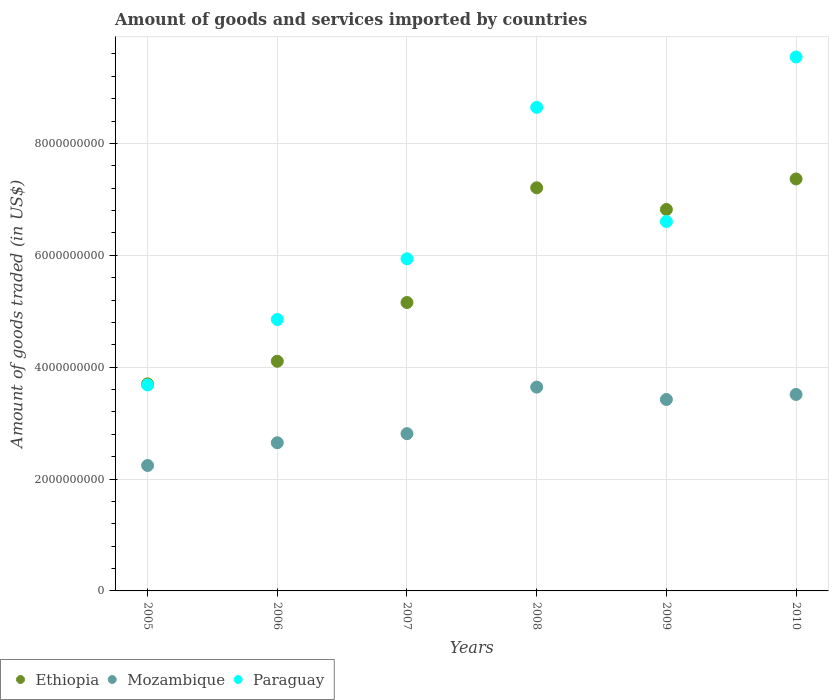Is the number of dotlines equal to the number of legend labels?
Your answer should be very brief. Yes. What is the total amount of goods and services imported in Paraguay in 2010?
Provide a short and direct response. 9.54e+09. Across all years, what is the maximum total amount of goods and services imported in Ethiopia?
Offer a terse response. 7.36e+09. Across all years, what is the minimum total amount of goods and services imported in Ethiopia?
Provide a short and direct response. 3.70e+09. In which year was the total amount of goods and services imported in Paraguay minimum?
Make the answer very short. 2005. What is the total total amount of goods and services imported in Ethiopia in the graph?
Your answer should be compact. 3.44e+1. What is the difference between the total amount of goods and services imported in Paraguay in 2008 and that in 2009?
Your answer should be compact. 2.04e+09. What is the difference between the total amount of goods and services imported in Mozambique in 2006 and the total amount of goods and services imported in Ethiopia in 2009?
Offer a very short reply. -4.17e+09. What is the average total amount of goods and services imported in Paraguay per year?
Offer a terse response. 6.54e+09. In the year 2010, what is the difference between the total amount of goods and services imported in Paraguay and total amount of goods and services imported in Mozambique?
Your response must be concise. 6.03e+09. What is the ratio of the total amount of goods and services imported in Mozambique in 2005 to that in 2006?
Make the answer very short. 0.85. Is the total amount of goods and services imported in Ethiopia in 2005 less than that in 2006?
Provide a short and direct response. Yes. Is the difference between the total amount of goods and services imported in Paraguay in 2007 and 2008 greater than the difference between the total amount of goods and services imported in Mozambique in 2007 and 2008?
Keep it short and to the point. No. What is the difference between the highest and the second highest total amount of goods and services imported in Mozambique?
Ensure brevity in your answer.  1.31e+08. What is the difference between the highest and the lowest total amount of goods and services imported in Ethiopia?
Give a very brief answer. 3.66e+09. Is the total amount of goods and services imported in Ethiopia strictly greater than the total amount of goods and services imported in Mozambique over the years?
Provide a succinct answer. Yes. Is the total amount of goods and services imported in Mozambique strictly less than the total amount of goods and services imported in Ethiopia over the years?
Your answer should be compact. Yes. How many years are there in the graph?
Ensure brevity in your answer.  6. Are the values on the major ticks of Y-axis written in scientific E-notation?
Keep it short and to the point. No. Does the graph contain any zero values?
Keep it short and to the point. No. Does the graph contain grids?
Your answer should be very brief. Yes. Where does the legend appear in the graph?
Your answer should be compact. Bottom left. How many legend labels are there?
Offer a very short reply. 3. What is the title of the graph?
Give a very brief answer. Amount of goods and services imported by countries. What is the label or title of the Y-axis?
Your answer should be compact. Amount of goods traded (in US$). What is the Amount of goods traded (in US$) of Ethiopia in 2005?
Your answer should be very brief. 3.70e+09. What is the Amount of goods traded (in US$) of Mozambique in 2005?
Provide a succinct answer. 2.24e+09. What is the Amount of goods traded (in US$) of Paraguay in 2005?
Provide a short and direct response. 3.68e+09. What is the Amount of goods traded (in US$) in Ethiopia in 2006?
Your answer should be very brief. 4.11e+09. What is the Amount of goods traded (in US$) in Mozambique in 2006?
Keep it short and to the point. 2.65e+09. What is the Amount of goods traded (in US$) in Paraguay in 2006?
Provide a succinct answer. 4.85e+09. What is the Amount of goods traded (in US$) of Ethiopia in 2007?
Your answer should be very brief. 5.16e+09. What is the Amount of goods traded (in US$) of Mozambique in 2007?
Provide a short and direct response. 2.81e+09. What is the Amount of goods traded (in US$) in Paraguay in 2007?
Offer a very short reply. 5.94e+09. What is the Amount of goods traded (in US$) in Ethiopia in 2008?
Offer a terse response. 7.21e+09. What is the Amount of goods traded (in US$) in Mozambique in 2008?
Offer a terse response. 3.64e+09. What is the Amount of goods traded (in US$) of Paraguay in 2008?
Ensure brevity in your answer.  8.64e+09. What is the Amount of goods traded (in US$) of Ethiopia in 2009?
Your answer should be compact. 6.82e+09. What is the Amount of goods traded (in US$) in Mozambique in 2009?
Your response must be concise. 3.42e+09. What is the Amount of goods traded (in US$) of Paraguay in 2009?
Ensure brevity in your answer.  6.60e+09. What is the Amount of goods traded (in US$) in Ethiopia in 2010?
Make the answer very short. 7.36e+09. What is the Amount of goods traded (in US$) of Mozambique in 2010?
Your response must be concise. 3.51e+09. What is the Amount of goods traded (in US$) in Paraguay in 2010?
Your answer should be very brief. 9.54e+09. Across all years, what is the maximum Amount of goods traded (in US$) in Ethiopia?
Give a very brief answer. 7.36e+09. Across all years, what is the maximum Amount of goods traded (in US$) in Mozambique?
Make the answer very short. 3.64e+09. Across all years, what is the maximum Amount of goods traded (in US$) of Paraguay?
Your answer should be very brief. 9.54e+09. Across all years, what is the minimum Amount of goods traded (in US$) of Ethiopia?
Your answer should be very brief. 3.70e+09. Across all years, what is the minimum Amount of goods traded (in US$) in Mozambique?
Provide a short and direct response. 2.24e+09. Across all years, what is the minimum Amount of goods traded (in US$) in Paraguay?
Your answer should be compact. 3.68e+09. What is the total Amount of goods traded (in US$) of Ethiopia in the graph?
Keep it short and to the point. 3.44e+1. What is the total Amount of goods traded (in US$) in Mozambique in the graph?
Provide a short and direct response. 1.83e+1. What is the total Amount of goods traded (in US$) in Paraguay in the graph?
Your response must be concise. 3.93e+1. What is the difference between the Amount of goods traded (in US$) of Ethiopia in 2005 and that in 2006?
Make the answer very short. -4.05e+08. What is the difference between the Amount of goods traded (in US$) in Mozambique in 2005 and that in 2006?
Keep it short and to the point. -4.07e+08. What is the difference between the Amount of goods traded (in US$) in Paraguay in 2005 and that in 2006?
Your answer should be compact. -1.17e+09. What is the difference between the Amount of goods traded (in US$) in Ethiopia in 2005 and that in 2007?
Offer a terse response. -1.45e+09. What is the difference between the Amount of goods traded (in US$) in Mozambique in 2005 and that in 2007?
Make the answer very short. -5.69e+08. What is the difference between the Amount of goods traded (in US$) in Paraguay in 2005 and that in 2007?
Provide a succinct answer. -2.26e+09. What is the difference between the Amount of goods traded (in US$) of Ethiopia in 2005 and that in 2008?
Your answer should be compact. -3.51e+09. What is the difference between the Amount of goods traded (in US$) in Mozambique in 2005 and that in 2008?
Your response must be concise. -1.40e+09. What is the difference between the Amount of goods traded (in US$) of Paraguay in 2005 and that in 2008?
Keep it short and to the point. -4.96e+09. What is the difference between the Amount of goods traded (in US$) of Ethiopia in 2005 and that in 2009?
Offer a terse response. -3.12e+09. What is the difference between the Amount of goods traded (in US$) in Mozambique in 2005 and that in 2009?
Give a very brief answer. -1.18e+09. What is the difference between the Amount of goods traded (in US$) of Paraguay in 2005 and that in 2009?
Provide a succinct answer. -2.92e+09. What is the difference between the Amount of goods traded (in US$) in Ethiopia in 2005 and that in 2010?
Your response must be concise. -3.66e+09. What is the difference between the Amount of goods traded (in US$) in Mozambique in 2005 and that in 2010?
Your response must be concise. -1.27e+09. What is the difference between the Amount of goods traded (in US$) in Paraguay in 2005 and that in 2010?
Provide a short and direct response. -5.86e+09. What is the difference between the Amount of goods traded (in US$) of Ethiopia in 2006 and that in 2007?
Offer a terse response. -1.05e+09. What is the difference between the Amount of goods traded (in US$) in Mozambique in 2006 and that in 2007?
Provide a short and direct response. -1.62e+08. What is the difference between the Amount of goods traded (in US$) of Paraguay in 2006 and that in 2007?
Offer a terse response. -1.08e+09. What is the difference between the Amount of goods traded (in US$) of Ethiopia in 2006 and that in 2008?
Offer a terse response. -3.10e+09. What is the difference between the Amount of goods traded (in US$) of Mozambique in 2006 and that in 2008?
Your answer should be compact. -9.95e+08. What is the difference between the Amount of goods traded (in US$) in Paraguay in 2006 and that in 2008?
Give a very brief answer. -3.79e+09. What is the difference between the Amount of goods traded (in US$) of Ethiopia in 2006 and that in 2009?
Offer a very short reply. -2.71e+09. What is the difference between the Amount of goods traded (in US$) of Mozambique in 2006 and that in 2009?
Ensure brevity in your answer.  -7.73e+08. What is the difference between the Amount of goods traded (in US$) in Paraguay in 2006 and that in 2009?
Your answer should be very brief. -1.75e+09. What is the difference between the Amount of goods traded (in US$) of Ethiopia in 2006 and that in 2010?
Your response must be concise. -3.26e+09. What is the difference between the Amount of goods traded (in US$) in Mozambique in 2006 and that in 2010?
Your answer should be compact. -8.64e+08. What is the difference between the Amount of goods traded (in US$) of Paraguay in 2006 and that in 2010?
Provide a succinct answer. -4.69e+09. What is the difference between the Amount of goods traded (in US$) of Ethiopia in 2007 and that in 2008?
Ensure brevity in your answer.  -2.05e+09. What is the difference between the Amount of goods traded (in US$) in Mozambique in 2007 and that in 2008?
Keep it short and to the point. -8.32e+08. What is the difference between the Amount of goods traded (in US$) in Paraguay in 2007 and that in 2008?
Give a very brief answer. -2.71e+09. What is the difference between the Amount of goods traded (in US$) in Ethiopia in 2007 and that in 2009?
Your answer should be very brief. -1.66e+09. What is the difference between the Amount of goods traded (in US$) in Mozambique in 2007 and that in 2009?
Make the answer very short. -6.11e+08. What is the difference between the Amount of goods traded (in US$) in Paraguay in 2007 and that in 2009?
Offer a very short reply. -6.66e+08. What is the difference between the Amount of goods traded (in US$) of Ethiopia in 2007 and that in 2010?
Ensure brevity in your answer.  -2.21e+09. What is the difference between the Amount of goods traded (in US$) of Mozambique in 2007 and that in 2010?
Provide a short and direct response. -7.01e+08. What is the difference between the Amount of goods traded (in US$) in Paraguay in 2007 and that in 2010?
Keep it short and to the point. -3.61e+09. What is the difference between the Amount of goods traded (in US$) in Ethiopia in 2008 and that in 2009?
Keep it short and to the point. 3.87e+08. What is the difference between the Amount of goods traded (in US$) in Mozambique in 2008 and that in 2009?
Make the answer very short. 2.21e+08. What is the difference between the Amount of goods traded (in US$) of Paraguay in 2008 and that in 2009?
Provide a succinct answer. 2.04e+09. What is the difference between the Amount of goods traded (in US$) of Ethiopia in 2008 and that in 2010?
Keep it short and to the point. -1.58e+08. What is the difference between the Amount of goods traded (in US$) in Mozambique in 2008 and that in 2010?
Offer a terse response. 1.31e+08. What is the difference between the Amount of goods traded (in US$) in Paraguay in 2008 and that in 2010?
Ensure brevity in your answer.  -9.00e+08. What is the difference between the Amount of goods traded (in US$) in Ethiopia in 2009 and that in 2010?
Your answer should be compact. -5.45e+08. What is the difference between the Amount of goods traded (in US$) of Mozambique in 2009 and that in 2010?
Make the answer very short. -9.04e+07. What is the difference between the Amount of goods traded (in US$) of Paraguay in 2009 and that in 2010?
Ensure brevity in your answer.  -2.94e+09. What is the difference between the Amount of goods traded (in US$) of Ethiopia in 2005 and the Amount of goods traded (in US$) of Mozambique in 2006?
Offer a very short reply. 1.05e+09. What is the difference between the Amount of goods traded (in US$) of Ethiopia in 2005 and the Amount of goods traded (in US$) of Paraguay in 2006?
Offer a very short reply. -1.15e+09. What is the difference between the Amount of goods traded (in US$) in Mozambique in 2005 and the Amount of goods traded (in US$) in Paraguay in 2006?
Provide a short and direct response. -2.61e+09. What is the difference between the Amount of goods traded (in US$) of Ethiopia in 2005 and the Amount of goods traded (in US$) of Mozambique in 2007?
Offer a terse response. 8.90e+08. What is the difference between the Amount of goods traded (in US$) of Ethiopia in 2005 and the Amount of goods traded (in US$) of Paraguay in 2007?
Keep it short and to the point. -2.24e+09. What is the difference between the Amount of goods traded (in US$) in Mozambique in 2005 and the Amount of goods traded (in US$) in Paraguay in 2007?
Offer a terse response. -3.70e+09. What is the difference between the Amount of goods traded (in US$) in Ethiopia in 2005 and the Amount of goods traded (in US$) in Mozambique in 2008?
Keep it short and to the point. 5.74e+07. What is the difference between the Amount of goods traded (in US$) of Ethiopia in 2005 and the Amount of goods traded (in US$) of Paraguay in 2008?
Your response must be concise. -4.94e+09. What is the difference between the Amount of goods traded (in US$) in Mozambique in 2005 and the Amount of goods traded (in US$) in Paraguay in 2008?
Provide a succinct answer. -6.40e+09. What is the difference between the Amount of goods traded (in US$) in Ethiopia in 2005 and the Amount of goods traded (in US$) in Mozambique in 2009?
Give a very brief answer. 2.79e+08. What is the difference between the Amount of goods traded (in US$) in Ethiopia in 2005 and the Amount of goods traded (in US$) in Paraguay in 2009?
Keep it short and to the point. -2.90e+09. What is the difference between the Amount of goods traded (in US$) of Mozambique in 2005 and the Amount of goods traded (in US$) of Paraguay in 2009?
Ensure brevity in your answer.  -4.36e+09. What is the difference between the Amount of goods traded (in US$) of Ethiopia in 2005 and the Amount of goods traded (in US$) of Mozambique in 2010?
Make the answer very short. 1.88e+08. What is the difference between the Amount of goods traded (in US$) in Ethiopia in 2005 and the Amount of goods traded (in US$) in Paraguay in 2010?
Your answer should be compact. -5.84e+09. What is the difference between the Amount of goods traded (in US$) in Mozambique in 2005 and the Amount of goods traded (in US$) in Paraguay in 2010?
Your answer should be compact. -7.30e+09. What is the difference between the Amount of goods traded (in US$) in Ethiopia in 2006 and the Amount of goods traded (in US$) in Mozambique in 2007?
Make the answer very short. 1.29e+09. What is the difference between the Amount of goods traded (in US$) of Ethiopia in 2006 and the Amount of goods traded (in US$) of Paraguay in 2007?
Provide a succinct answer. -1.83e+09. What is the difference between the Amount of goods traded (in US$) of Mozambique in 2006 and the Amount of goods traded (in US$) of Paraguay in 2007?
Offer a terse response. -3.29e+09. What is the difference between the Amount of goods traded (in US$) in Ethiopia in 2006 and the Amount of goods traded (in US$) in Mozambique in 2008?
Make the answer very short. 4.62e+08. What is the difference between the Amount of goods traded (in US$) in Ethiopia in 2006 and the Amount of goods traded (in US$) in Paraguay in 2008?
Offer a very short reply. -4.54e+09. What is the difference between the Amount of goods traded (in US$) in Mozambique in 2006 and the Amount of goods traded (in US$) in Paraguay in 2008?
Offer a very short reply. -6.00e+09. What is the difference between the Amount of goods traded (in US$) in Ethiopia in 2006 and the Amount of goods traded (in US$) in Mozambique in 2009?
Your answer should be very brief. 6.84e+08. What is the difference between the Amount of goods traded (in US$) in Ethiopia in 2006 and the Amount of goods traded (in US$) in Paraguay in 2009?
Your response must be concise. -2.50e+09. What is the difference between the Amount of goods traded (in US$) in Mozambique in 2006 and the Amount of goods traded (in US$) in Paraguay in 2009?
Provide a succinct answer. -3.95e+09. What is the difference between the Amount of goods traded (in US$) in Ethiopia in 2006 and the Amount of goods traded (in US$) in Mozambique in 2010?
Provide a short and direct response. 5.93e+08. What is the difference between the Amount of goods traded (in US$) of Ethiopia in 2006 and the Amount of goods traded (in US$) of Paraguay in 2010?
Your answer should be very brief. -5.44e+09. What is the difference between the Amount of goods traded (in US$) in Mozambique in 2006 and the Amount of goods traded (in US$) in Paraguay in 2010?
Keep it short and to the point. -6.90e+09. What is the difference between the Amount of goods traded (in US$) of Ethiopia in 2007 and the Amount of goods traded (in US$) of Mozambique in 2008?
Offer a very short reply. 1.51e+09. What is the difference between the Amount of goods traded (in US$) in Ethiopia in 2007 and the Amount of goods traded (in US$) in Paraguay in 2008?
Give a very brief answer. -3.49e+09. What is the difference between the Amount of goods traded (in US$) of Mozambique in 2007 and the Amount of goods traded (in US$) of Paraguay in 2008?
Your answer should be very brief. -5.83e+09. What is the difference between the Amount of goods traded (in US$) of Ethiopia in 2007 and the Amount of goods traded (in US$) of Mozambique in 2009?
Your response must be concise. 1.73e+09. What is the difference between the Amount of goods traded (in US$) of Ethiopia in 2007 and the Amount of goods traded (in US$) of Paraguay in 2009?
Your answer should be very brief. -1.45e+09. What is the difference between the Amount of goods traded (in US$) in Mozambique in 2007 and the Amount of goods traded (in US$) in Paraguay in 2009?
Ensure brevity in your answer.  -3.79e+09. What is the difference between the Amount of goods traded (in US$) in Ethiopia in 2007 and the Amount of goods traded (in US$) in Mozambique in 2010?
Your response must be concise. 1.64e+09. What is the difference between the Amount of goods traded (in US$) of Ethiopia in 2007 and the Amount of goods traded (in US$) of Paraguay in 2010?
Provide a succinct answer. -4.39e+09. What is the difference between the Amount of goods traded (in US$) in Mozambique in 2007 and the Amount of goods traded (in US$) in Paraguay in 2010?
Your answer should be very brief. -6.73e+09. What is the difference between the Amount of goods traded (in US$) of Ethiopia in 2008 and the Amount of goods traded (in US$) of Mozambique in 2009?
Your answer should be very brief. 3.78e+09. What is the difference between the Amount of goods traded (in US$) of Ethiopia in 2008 and the Amount of goods traded (in US$) of Paraguay in 2009?
Offer a terse response. 6.03e+08. What is the difference between the Amount of goods traded (in US$) in Mozambique in 2008 and the Amount of goods traded (in US$) in Paraguay in 2009?
Your answer should be very brief. -2.96e+09. What is the difference between the Amount of goods traded (in US$) in Ethiopia in 2008 and the Amount of goods traded (in US$) in Mozambique in 2010?
Provide a succinct answer. 3.69e+09. What is the difference between the Amount of goods traded (in US$) in Ethiopia in 2008 and the Amount of goods traded (in US$) in Paraguay in 2010?
Your answer should be compact. -2.34e+09. What is the difference between the Amount of goods traded (in US$) of Mozambique in 2008 and the Amount of goods traded (in US$) of Paraguay in 2010?
Provide a succinct answer. -5.90e+09. What is the difference between the Amount of goods traded (in US$) in Ethiopia in 2009 and the Amount of goods traded (in US$) in Mozambique in 2010?
Your response must be concise. 3.31e+09. What is the difference between the Amount of goods traded (in US$) in Ethiopia in 2009 and the Amount of goods traded (in US$) in Paraguay in 2010?
Offer a terse response. -2.73e+09. What is the difference between the Amount of goods traded (in US$) in Mozambique in 2009 and the Amount of goods traded (in US$) in Paraguay in 2010?
Your answer should be very brief. -6.12e+09. What is the average Amount of goods traded (in US$) of Ethiopia per year?
Make the answer very short. 5.73e+09. What is the average Amount of goods traded (in US$) in Mozambique per year?
Provide a succinct answer. 3.05e+09. What is the average Amount of goods traded (in US$) of Paraguay per year?
Your answer should be compact. 6.54e+09. In the year 2005, what is the difference between the Amount of goods traded (in US$) in Ethiopia and Amount of goods traded (in US$) in Mozambique?
Offer a terse response. 1.46e+09. In the year 2005, what is the difference between the Amount of goods traded (in US$) of Ethiopia and Amount of goods traded (in US$) of Paraguay?
Make the answer very short. 1.88e+07. In the year 2005, what is the difference between the Amount of goods traded (in US$) of Mozambique and Amount of goods traded (in US$) of Paraguay?
Your answer should be very brief. -1.44e+09. In the year 2006, what is the difference between the Amount of goods traded (in US$) of Ethiopia and Amount of goods traded (in US$) of Mozambique?
Provide a succinct answer. 1.46e+09. In the year 2006, what is the difference between the Amount of goods traded (in US$) in Ethiopia and Amount of goods traded (in US$) in Paraguay?
Offer a very short reply. -7.47e+08. In the year 2006, what is the difference between the Amount of goods traded (in US$) in Mozambique and Amount of goods traded (in US$) in Paraguay?
Make the answer very short. -2.20e+09. In the year 2007, what is the difference between the Amount of goods traded (in US$) of Ethiopia and Amount of goods traded (in US$) of Mozambique?
Provide a short and direct response. 2.34e+09. In the year 2007, what is the difference between the Amount of goods traded (in US$) in Ethiopia and Amount of goods traded (in US$) in Paraguay?
Your answer should be compact. -7.82e+08. In the year 2007, what is the difference between the Amount of goods traded (in US$) of Mozambique and Amount of goods traded (in US$) of Paraguay?
Offer a very short reply. -3.13e+09. In the year 2008, what is the difference between the Amount of goods traded (in US$) of Ethiopia and Amount of goods traded (in US$) of Mozambique?
Offer a very short reply. 3.56e+09. In the year 2008, what is the difference between the Amount of goods traded (in US$) of Ethiopia and Amount of goods traded (in US$) of Paraguay?
Make the answer very short. -1.44e+09. In the year 2008, what is the difference between the Amount of goods traded (in US$) of Mozambique and Amount of goods traded (in US$) of Paraguay?
Keep it short and to the point. -5.00e+09. In the year 2009, what is the difference between the Amount of goods traded (in US$) of Ethiopia and Amount of goods traded (in US$) of Mozambique?
Your answer should be compact. 3.40e+09. In the year 2009, what is the difference between the Amount of goods traded (in US$) of Ethiopia and Amount of goods traded (in US$) of Paraguay?
Give a very brief answer. 2.16e+08. In the year 2009, what is the difference between the Amount of goods traded (in US$) of Mozambique and Amount of goods traded (in US$) of Paraguay?
Keep it short and to the point. -3.18e+09. In the year 2010, what is the difference between the Amount of goods traded (in US$) in Ethiopia and Amount of goods traded (in US$) in Mozambique?
Provide a short and direct response. 3.85e+09. In the year 2010, what is the difference between the Amount of goods traded (in US$) in Ethiopia and Amount of goods traded (in US$) in Paraguay?
Give a very brief answer. -2.18e+09. In the year 2010, what is the difference between the Amount of goods traded (in US$) of Mozambique and Amount of goods traded (in US$) of Paraguay?
Your answer should be very brief. -6.03e+09. What is the ratio of the Amount of goods traded (in US$) in Ethiopia in 2005 to that in 2006?
Your answer should be compact. 0.9. What is the ratio of the Amount of goods traded (in US$) in Mozambique in 2005 to that in 2006?
Provide a succinct answer. 0.85. What is the ratio of the Amount of goods traded (in US$) of Paraguay in 2005 to that in 2006?
Provide a short and direct response. 0.76. What is the ratio of the Amount of goods traded (in US$) of Ethiopia in 2005 to that in 2007?
Give a very brief answer. 0.72. What is the ratio of the Amount of goods traded (in US$) in Mozambique in 2005 to that in 2007?
Offer a very short reply. 0.8. What is the ratio of the Amount of goods traded (in US$) in Paraguay in 2005 to that in 2007?
Make the answer very short. 0.62. What is the ratio of the Amount of goods traded (in US$) in Ethiopia in 2005 to that in 2008?
Offer a terse response. 0.51. What is the ratio of the Amount of goods traded (in US$) in Mozambique in 2005 to that in 2008?
Ensure brevity in your answer.  0.62. What is the ratio of the Amount of goods traded (in US$) in Paraguay in 2005 to that in 2008?
Keep it short and to the point. 0.43. What is the ratio of the Amount of goods traded (in US$) in Ethiopia in 2005 to that in 2009?
Your answer should be very brief. 0.54. What is the ratio of the Amount of goods traded (in US$) in Mozambique in 2005 to that in 2009?
Your response must be concise. 0.66. What is the ratio of the Amount of goods traded (in US$) of Paraguay in 2005 to that in 2009?
Provide a short and direct response. 0.56. What is the ratio of the Amount of goods traded (in US$) of Ethiopia in 2005 to that in 2010?
Your response must be concise. 0.5. What is the ratio of the Amount of goods traded (in US$) of Mozambique in 2005 to that in 2010?
Your answer should be compact. 0.64. What is the ratio of the Amount of goods traded (in US$) in Paraguay in 2005 to that in 2010?
Offer a very short reply. 0.39. What is the ratio of the Amount of goods traded (in US$) of Ethiopia in 2006 to that in 2007?
Ensure brevity in your answer.  0.8. What is the ratio of the Amount of goods traded (in US$) of Mozambique in 2006 to that in 2007?
Your response must be concise. 0.94. What is the ratio of the Amount of goods traded (in US$) in Paraguay in 2006 to that in 2007?
Offer a very short reply. 0.82. What is the ratio of the Amount of goods traded (in US$) in Ethiopia in 2006 to that in 2008?
Your response must be concise. 0.57. What is the ratio of the Amount of goods traded (in US$) of Mozambique in 2006 to that in 2008?
Give a very brief answer. 0.73. What is the ratio of the Amount of goods traded (in US$) of Paraguay in 2006 to that in 2008?
Your response must be concise. 0.56. What is the ratio of the Amount of goods traded (in US$) of Ethiopia in 2006 to that in 2009?
Your response must be concise. 0.6. What is the ratio of the Amount of goods traded (in US$) in Mozambique in 2006 to that in 2009?
Your answer should be compact. 0.77. What is the ratio of the Amount of goods traded (in US$) of Paraguay in 2006 to that in 2009?
Your answer should be very brief. 0.73. What is the ratio of the Amount of goods traded (in US$) in Ethiopia in 2006 to that in 2010?
Your answer should be compact. 0.56. What is the ratio of the Amount of goods traded (in US$) in Mozambique in 2006 to that in 2010?
Offer a terse response. 0.75. What is the ratio of the Amount of goods traded (in US$) of Paraguay in 2006 to that in 2010?
Ensure brevity in your answer.  0.51. What is the ratio of the Amount of goods traded (in US$) in Ethiopia in 2007 to that in 2008?
Your answer should be compact. 0.72. What is the ratio of the Amount of goods traded (in US$) in Mozambique in 2007 to that in 2008?
Provide a short and direct response. 0.77. What is the ratio of the Amount of goods traded (in US$) in Paraguay in 2007 to that in 2008?
Give a very brief answer. 0.69. What is the ratio of the Amount of goods traded (in US$) in Ethiopia in 2007 to that in 2009?
Your answer should be compact. 0.76. What is the ratio of the Amount of goods traded (in US$) in Mozambique in 2007 to that in 2009?
Your answer should be very brief. 0.82. What is the ratio of the Amount of goods traded (in US$) of Paraguay in 2007 to that in 2009?
Your response must be concise. 0.9. What is the ratio of the Amount of goods traded (in US$) of Ethiopia in 2007 to that in 2010?
Your response must be concise. 0.7. What is the ratio of the Amount of goods traded (in US$) in Mozambique in 2007 to that in 2010?
Make the answer very short. 0.8. What is the ratio of the Amount of goods traded (in US$) in Paraguay in 2007 to that in 2010?
Offer a terse response. 0.62. What is the ratio of the Amount of goods traded (in US$) in Ethiopia in 2008 to that in 2009?
Provide a short and direct response. 1.06. What is the ratio of the Amount of goods traded (in US$) in Mozambique in 2008 to that in 2009?
Your answer should be very brief. 1.06. What is the ratio of the Amount of goods traded (in US$) in Paraguay in 2008 to that in 2009?
Make the answer very short. 1.31. What is the ratio of the Amount of goods traded (in US$) of Ethiopia in 2008 to that in 2010?
Offer a terse response. 0.98. What is the ratio of the Amount of goods traded (in US$) in Mozambique in 2008 to that in 2010?
Your answer should be very brief. 1.04. What is the ratio of the Amount of goods traded (in US$) in Paraguay in 2008 to that in 2010?
Your response must be concise. 0.91. What is the ratio of the Amount of goods traded (in US$) in Ethiopia in 2009 to that in 2010?
Make the answer very short. 0.93. What is the ratio of the Amount of goods traded (in US$) of Mozambique in 2009 to that in 2010?
Offer a very short reply. 0.97. What is the ratio of the Amount of goods traded (in US$) of Paraguay in 2009 to that in 2010?
Ensure brevity in your answer.  0.69. What is the difference between the highest and the second highest Amount of goods traded (in US$) in Ethiopia?
Ensure brevity in your answer.  1.58e+08. What is the difference between the highest and the second highest Amount of goods traded (in US$) in Mozambique?
Ensure brevity in your answer.  1.31e+08. What is the difference between the highest and the second highest Amount of goods traded (in US$) of Paraguay?
Provide a short and direct response. 9.00e+08. What is the difference between the highest and the lowest Amount of goods traded (in US$) in Ethiopia?
Offer a very short reply. 3.66e+09. What is the difference between the highest and the lowest Amount of goods traded (in US$) in Mozambique?
Provide a succinct answer. 1.40e+09. What is the difference between the highest and the lowest Amount of goods traded (in US$) in Paraguay?
Provide a short and direct response. 5.86e+09. 